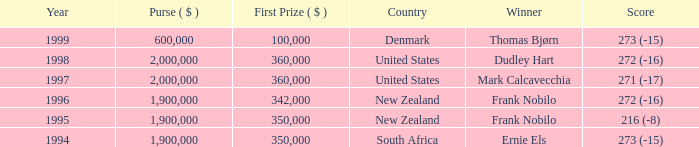What was the top first place prize in 1997? 360000.0. 